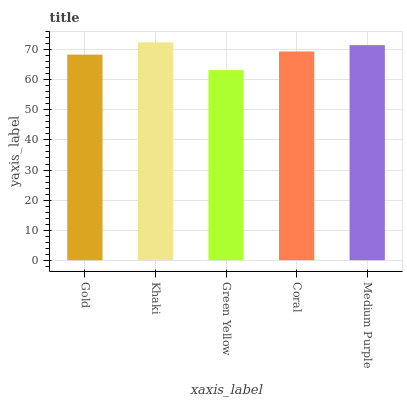Is Khaki the minimum?
Answer yes or no. No. Is Green Yellow the maximum?
Answer yes or no. No. Is Khaki greater than Green Yellow?
Answer yes or no. Yes. Is Green Yellow less than Khaki?
Answer yes or no. Yes. Is Green Yellow greater than Khaki?
Answer yes or no. No. Is Khaki less than Green Yellow?
Answer yes or no. No. Is Coral the high median?
Answer yes or no. Yes. Is Coral the low median?
Answer yes or no. Yes. Is Khaki the high median?
Answer yes or no. No. Is Khaki the low median?
Answer yes or no. No. 